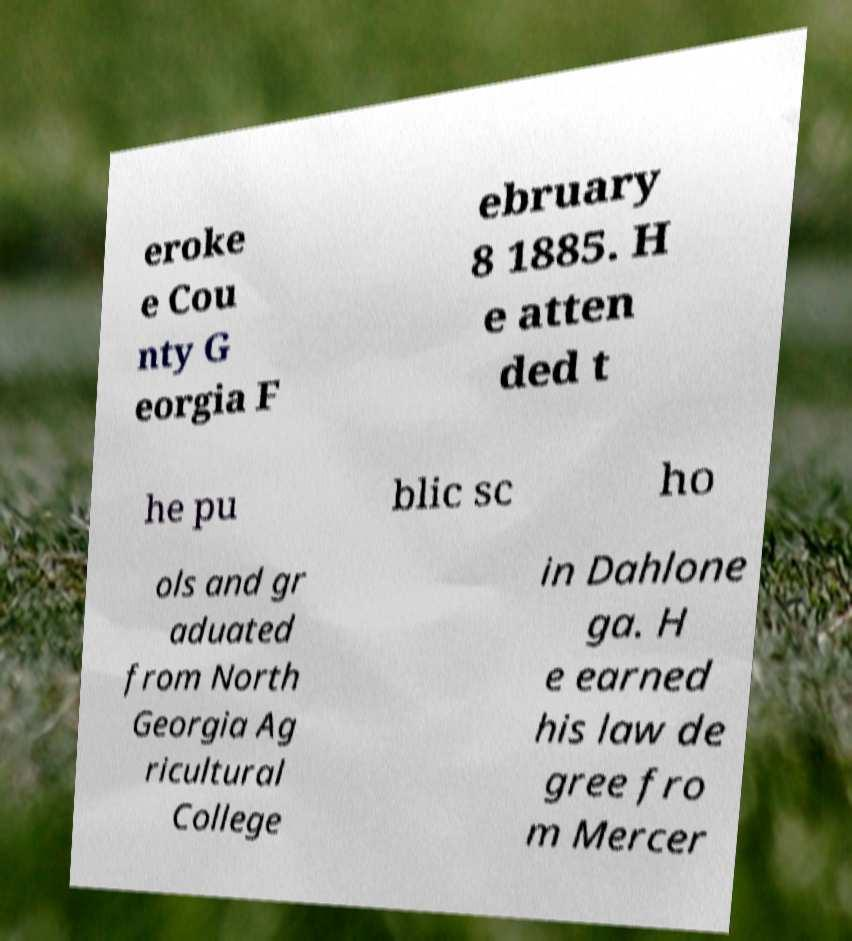There's text embedded in this image that I need extracted. Can you transcribe it verbatim? eroke e Cou nty G eorgia F ebruary 8 1885. H e atten ded t he pu blic sc ho ols and gr aduated from North Georgia Ag ricultural College in Dahlone ga. H e earned his law de gree fro m Mercer 